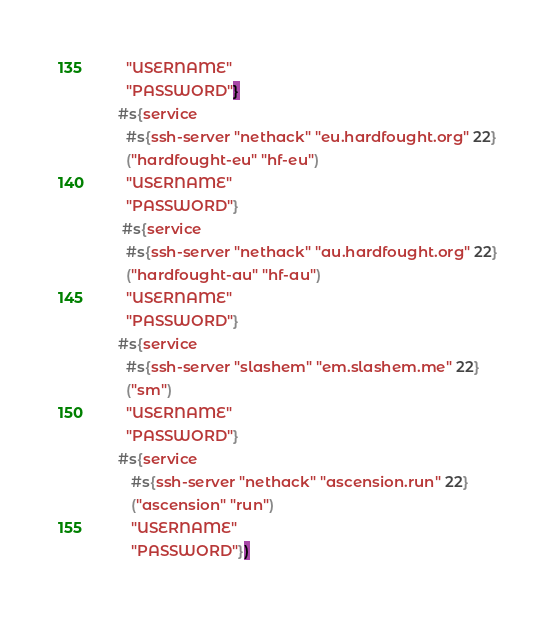<code> <loc_0><loc_0><loc_500><loc_500><_Racket_>   "USERNAME"
   "PASSWORD"}
 #s{service
   #s{ssh-server "nethack" "eu.hardfought.org" 22}
   ("hardfought-eu" "hf-eu")
   "USERNAME"
   "PASSWORD"}
  #s{service
   #s{ssh-server "nethack" "au.hardfought.org" 22}
   ("hardfought-au" "hf-au")
   "USERNAME"
   "PASSWORD"}
 #s{service
   #s{ssh-server "slashem" "em.slashem.me" 22}
   ("sm")
   "USERNAME"
   "PASSWORD"}
 #s{service
    #s{ssh-server "nethack" "ascension.run" 22}
    ("ascension" "run")
    "USERNAME"
    "PASSWORD"})
</code> 